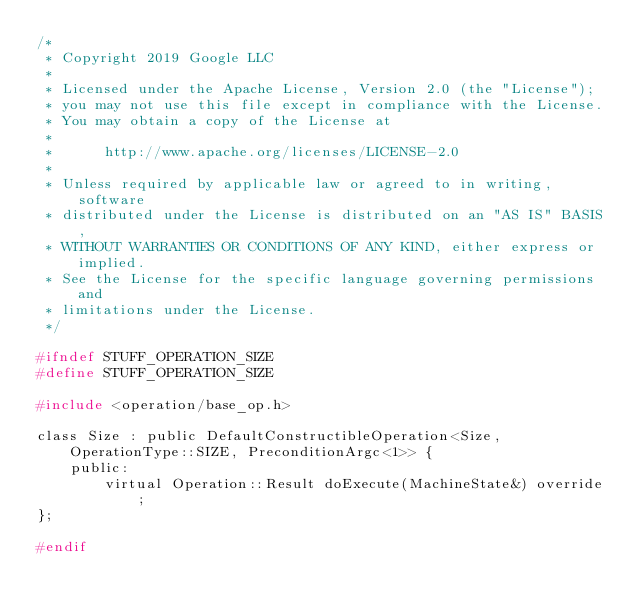<code> <loc_0><loc_0><loc_500><loc_500><_C_>/*
 * Copyright 2019 Google LLC
 *
 * Licensed under the Apache License, Version 2.0 (the "License");
 * you may not use this file except in compliance with the License.
 * You may obtain a copy of the License at
 *
 *      http://www.apache.org/licenses/LICENSE-2.0
 *
 * Unless required by applicable law or agreed to in writing, software
 * distributed under the License is distributed on an "AS IS" BASIS,
 * WITHOUT WARRANTIES OR CONDITIONS OF ANY KIND, either express or implied.
 * See the License for the specific language governing permissions and
 * limitations under the License.
 */

#ifndef STUFF_OPERATION_SIZE
#define STUFF_OPERATION_SIZE

#include <operation/base_op.h>

class Size : public DefaultConstructibleOperation<Size, OperationType::SIZE, PreconditionArgc<1>> {
    public:
        virtual Operation::Result doExecute(MachineState&) override;
};

#endif
</code> 